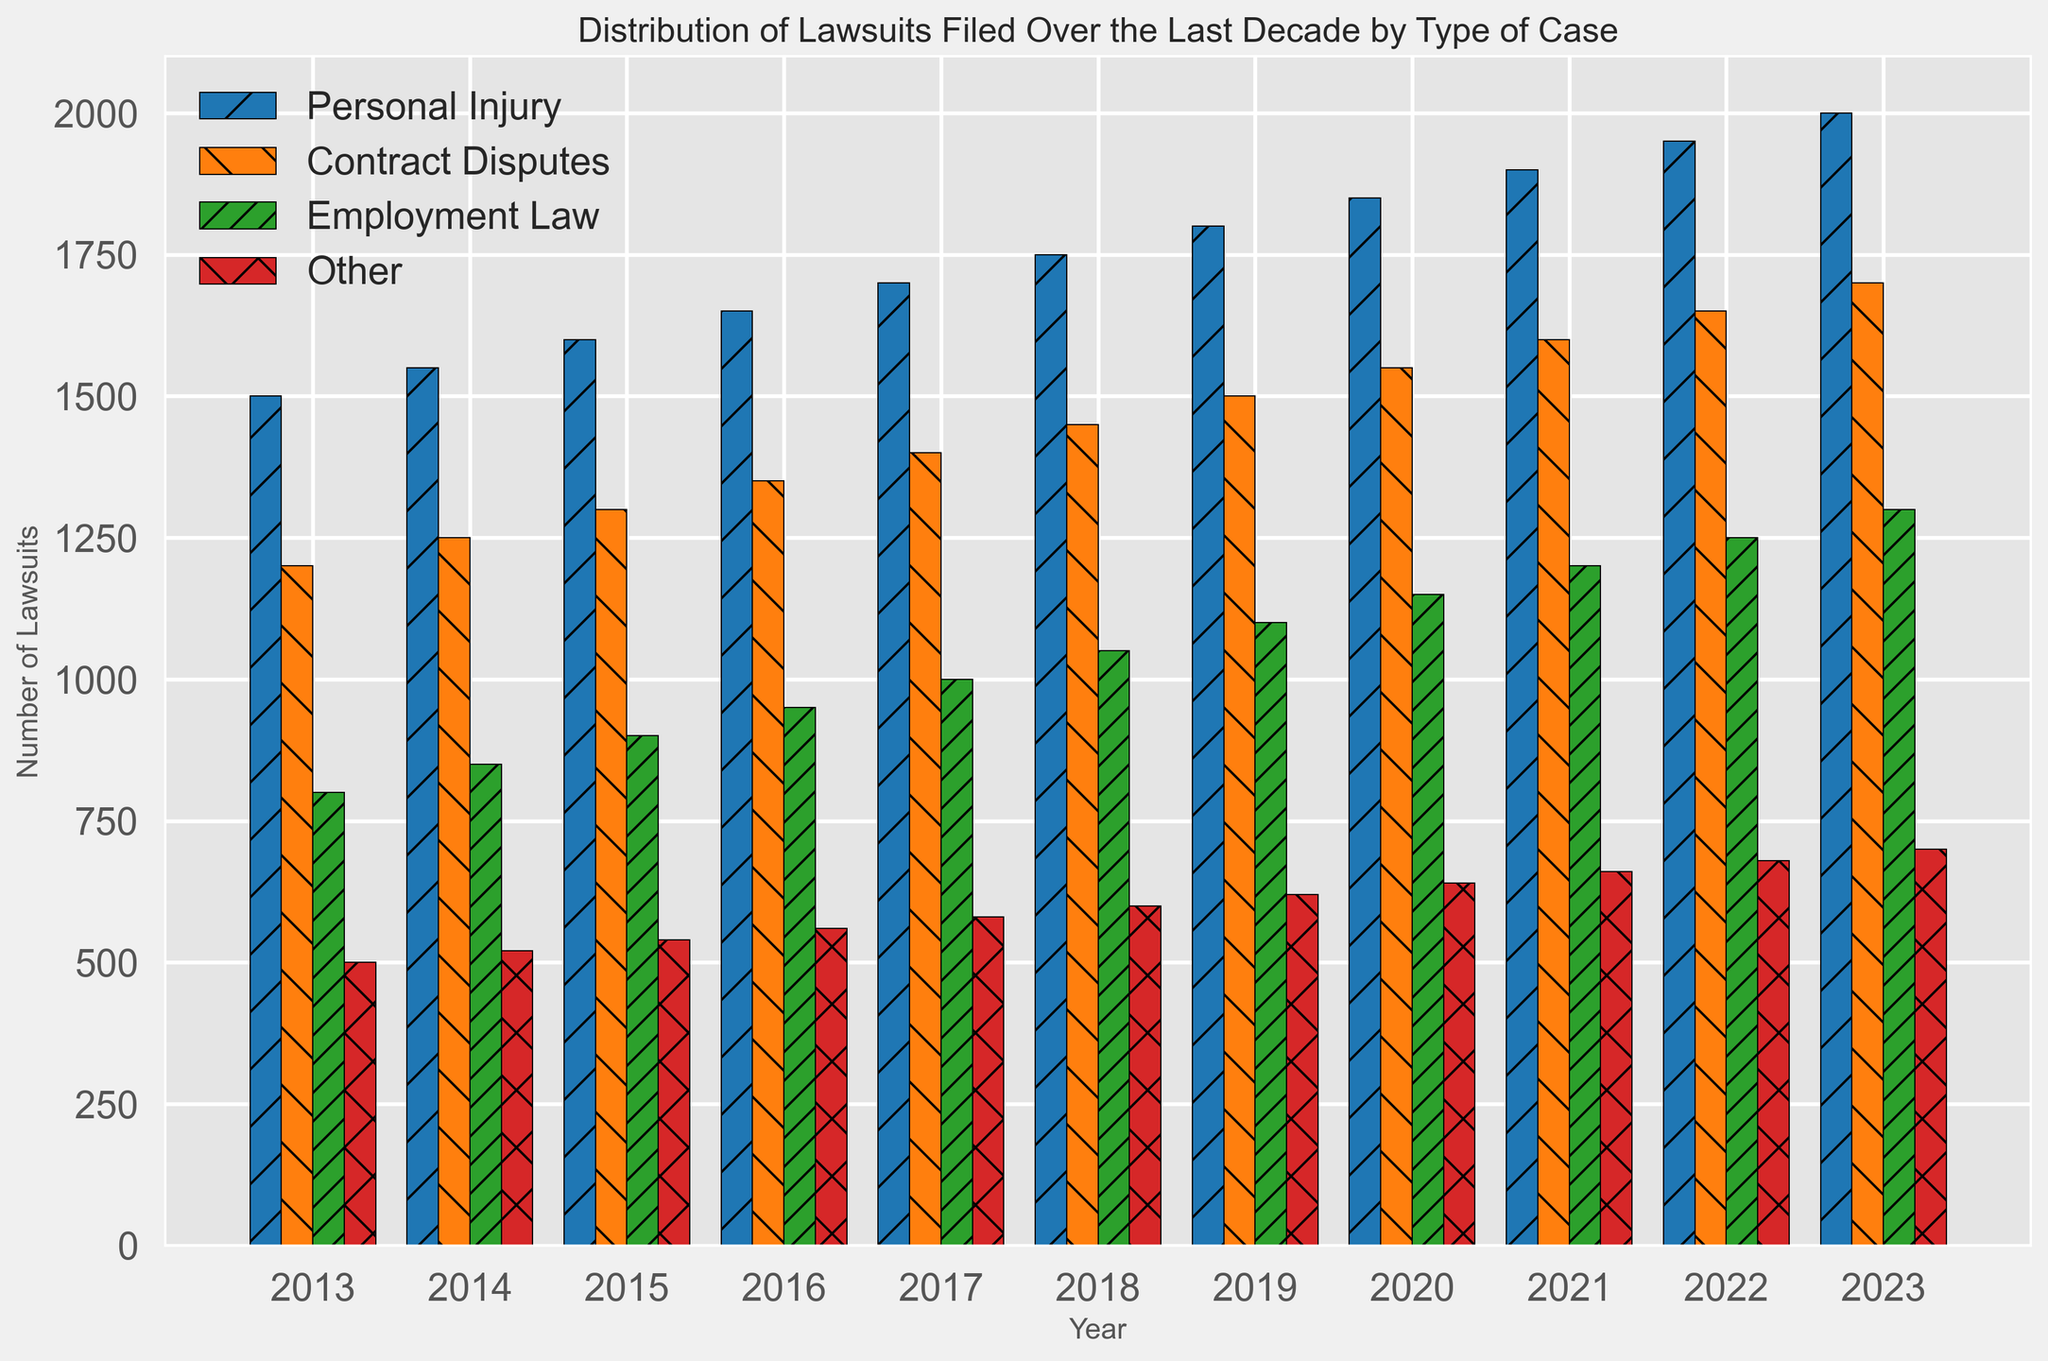What year had the highest number of "Personal Injury" lawsuits filed? Look at the blue bars representing "Personal Injury" lawsuits and find the tallest one. The tallest blue bar corresponds to the year 2023.
Answer: 2023 Which type of lawsuit had the most significant increase over the last decade? Compare the heights of the bars for each lawsuit type from 2013 to 2023. "Personal Injury" lawsuits increased from 1500 to 2000, whereas other types had smaller increases.
Answer: Personal Injury What is the total number of "Contract Disputes" lawsuits filed in the first and last years combined? Sum the numbers for "Contract Disputes" in 2013 and 2023. The values are 1200 and 1700 respectively, so the total is 1200 + 1700 = 2900.
Answer: 2900 Between 2013 and 2018, which type of cases saw the smallest increase in the number of lawsuits filed? Calculate the increase for each case type from 2013 to 2018: Personal Injury (250), Contract Disputes (250), Employment Law (250), and Other (100). "Other" saw the smallest increase of 100.
Answer: Other How does the number of "Employment Law" lawsuits in 2021 compare to "Other" lawsuits in 2023? Observe the green bar for "Employment Law" in 2021 which is at 1200, and the red bar for "Other" in 2023 which is at 700. 1200 is greater than 700.
Answer: Employment Law in 2021 is higher What is the average number of "Personal Injury" lawsuits filed per year over the last decade? Sum all "Personal Injury" values and divide by the number of years: (1500 + 1550 + 1600 + 1650 + 1700 + 1750 + 1800 + 1850 + 1900 + 1950 + 2000) / 11 = 1750.
Answer: 1750 Which two years had the closest number of "Contract Disputes" lawsuits filed? Compare the "Contract Disputes" values for consecutive years: the smallest difference is between 2022 and 2023 with one year having 1650 and the other 1700, so the difference is only 50.
Answer: 2022 and 2023 What is the difference in the number of "Other" lawsuits filed between the years 2013 and 2023? Subtract the number of "Other" lawsuits in 2013 from that in 2023: 700 - 500 = 200.
Answer: 200 Does "Employment Law" or "Personal Injury" have a greater rate of increase from 2015 to 2020? Calculate the rates of increase: Employment Law goes from 900 to 1150 which is an increase of 250; Personal Injury goes from 1600 to 1850 which is an increase of 250. Both have the same rate of increase.
Answer: Same 